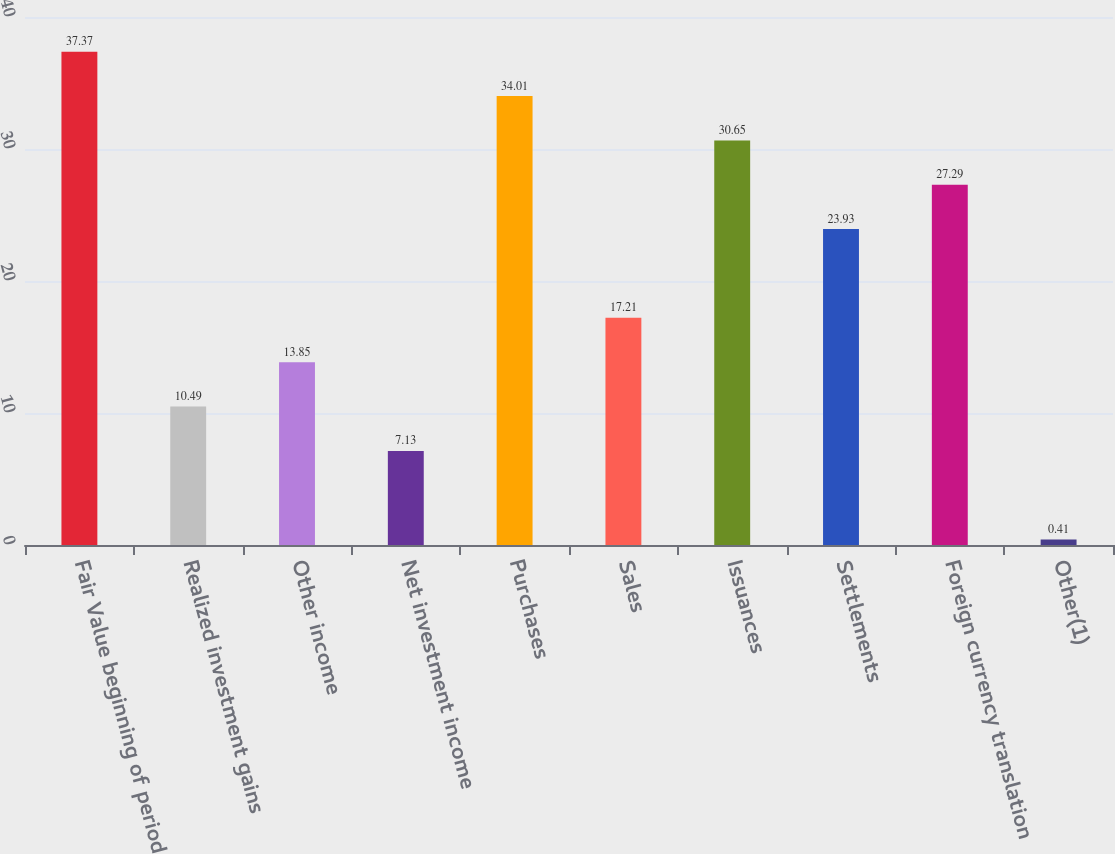Convert chart. <chart><loc_0><loc_0><loc_500><loc_500><bar_chart><fcel>Fair Value beginning of period<fcel>Realized investment gains<fcel>Other income<fcel>Net investment income<fcel>Purchases<fcel>Sales<fcel>Issuances<fcel>Settlements<fcel>Foreign currency translation<fcel>Other(1)<nl><fcel>37.37<fcel>10.49<fcel>13.85<fcel>7.13<fcel>34.01<fcel>17.21<fcel>30.65<fcel>23.93<fcel>27.29<fcel>0.41<nl></chart> 